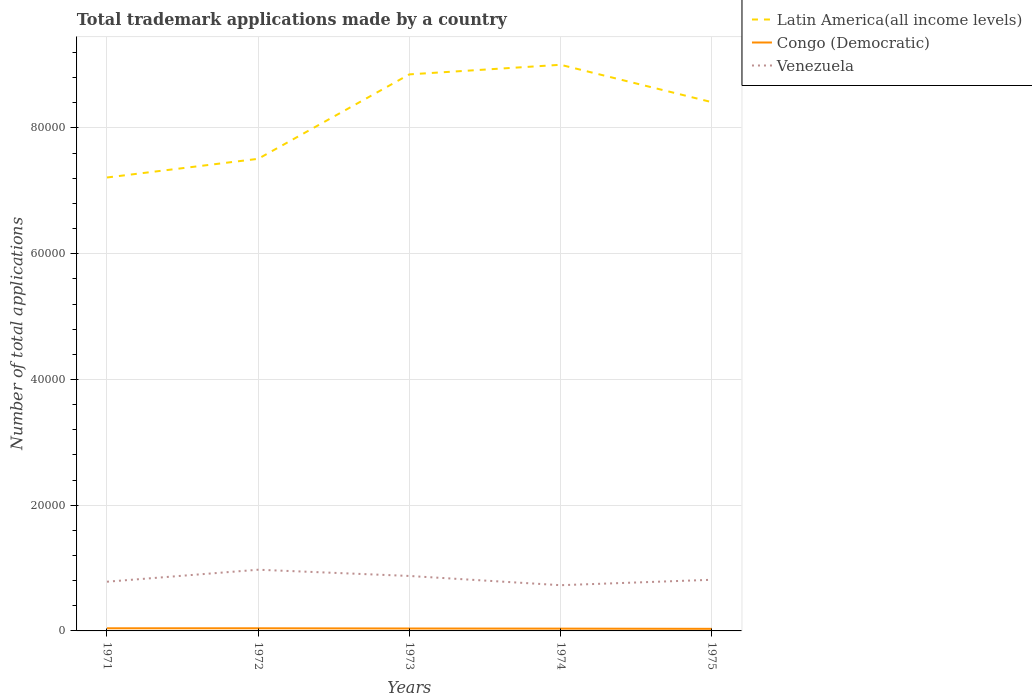Across all years, what is the maximum number of applications made by in Congo (Democratic)?
Keep it short and to the point. 334. In which year was the number of applications made by in Venezuela maximum?
Ensure brevity in your answer.  1974. What is the total number of applications made by in Congo (Democratic) in the graph?
Your answer should be very brief. 86. What is the difference between the highest and the lowest number of applications made by in Venezuela?
Ensure brevity in your answer.  2. Is the number of applications made by in Congo (Democratic) strictly greater than the number of applications made by in Latin America(all income levels) over the years?
Your response must be concise. Yes. Are the values on the major ticks of Y-axis written in scientific E-notation?
Make the answer very short. No. Does the graph contain any zero values?
Provide a short and direct response. No. Where does the legend appear in the graph?
Make the answer very short. Top right. How many legend labels are there?
Offer a very short reply. 3. What is the title of the graph?
Make the answer very short. Total trademark applications made by a country. What is the label or title of the Y-axis?
Provide a short and direct response. Number of total applications. What is the Number of total applications in Latin America(all income levels) in 1971?
Provide a succinct answer. 7.21e+04. What is the Number of total applications of Congo (Democratic) in 1971?
Provide a succinct answer. 421. What is the Number of total applications in Venezuela in 1971?
Offer a very short reply. 7827. What is the Number of total applications of Latin America(all income levels) in 1972?
Keep it short and to the point. 7.51e+04. What is the Number of total applications of Congo (Democratic) in 1972?
Keep it short and to the point. 420. What is the Number of total applications in Venezuela in 1972?
Your answer should be very brief. 9735. What is the Number of total applications in Latin America(all income levels) in 1973?
Offer a very short reply. 8.85e+04. What is the Number of total applications of Congo (Democratic) in 1973?
Offer a terse response. 384. What is the Number of total applications of Venezuela in 1973?
Your answer should be compact. 8742. What is the Number of total applications of Latin America(all income levels) in 1974?
Keep it short and to the point. 9.01e+04. What is the Number of total applications of Congo (Democratic) in 1974?
Give a very brief answer. 366. What is the Number of total applications of Venezuela in 1974?
Offer a very short reply. 7272. What is the Number of total applications of Latin America(all income levels) in 1975?
Provide a succinct answer. 8.41e+04. What is the Number of total applications in Congo (Democratic) in 1975?
Ensure brevity in your answer.  334. What is the Number of total applications in Venezuela in 1975?
Provide a short and direct response. 8135. Across all years, what is the maximum Number of total applications in Latin America(all income levels)?
Offer a very short reply. 9.01e+04. Across all years, what is the maximum Number of total applications of Congo (Democratic)?
Keep it short and to the point. 421. Across all years, what is the maximum Number of total applications of Venezuela?
Make the answer very short. 9735. Across all years, what is the minimum Number of total applications in Latin America(all income levels)?
Your answer should be very brief. 7.21e+04. Across all years, what is the minimum Number of total applications in Congo (Democratic)?
Offer a very short reply. 334. Across all years, what is the minimum Number of total applications in Venezuela?
Make the answer very short. 7272. What is the total Number of total applications in Latin America(all income levels) in the graph?
Your answer should be very brief. 4.10e+05. What is the total Number of total applications of Congo (Democratic) in the graph?
Offer a very short reply. 1925. What is the total Number of total applications of Venezuela in the graph?
Provide a succinct answer. 4.17e+04. What is the difference between the Number of total applications of Latin America(all income levels) in 1971 and that in 1972?
Give a very brief answer. -2970. What is the difference between the Number of total applications in Congo (Democratic) in 1971 and that in 1972?
Your answer should be very brief. 1. What is the difference between the Number of total applications in Venezuela in 1971 and that in 1972?
Your answer should be very brief. -1908. What is the difference between the Number of total applications in Latin America(all income levels) in 1971 and that in 1973?
Offer a very short reply. -1.64e+04. What is the difference between the Number of total applications of Congo (Democratic) in 1971 and that in 1973?
Offer a terse response. 37. What is the difference between the Number of total applications in Venezuela in 1971 and that in 1973?
Your answer should be compact. -915. What is the difference between the Number of total applications in Latin America(all income levels) in 1971 and that in 1974?
Make the answer very short. -1.79e+04. What is the difference between the Number of total applications of Venezuela in 1971 and that in 1974?
Offer a terse response. 555. What is the difference between the Number of total applications in Latin America(all income levels) in 1971 and that in 1975?
Your answer should be very brief. -1.20e+04. What is the difference between the Number of total applications in Venezuela in 1971 and that in 1975?
Give a very brief answer. -308. What is the difference between the Number of total applications of Latin America(all income levels) in 1972 and that in 1973?
Your answer should be compact. -1.34e+04. What is the difference between the Number of total applications in Congo (Democratic) in 1972 and that in 1973?
Your response must be concise. 36. What is the difference between the Number of total applications of Venezuela in 1972 and that in 1973?
Your answer should be very brief. 993. What is the difference between the Number of total applications of Latin America(all income levels) in 1972 and that in 1974?
Ensure brevity in your answer.  -1.50e+04. What is the difference between the Number of total applications of Venezuela in 1972 and that in 1974?
Your response must be concise. 2463. What is the difference between the Number of total applications of Latin America(all income levels) in 1972 and that in 1975?
Keep it short and to the point. -9015. What is the difference between the Number of total applications of Venezuela in 1972 and that in 1975?
Provide a succinct answer. 1600. What is the difference between the Number of total applications of Latin America(all income levels) in 1973 and that in 1974?
Provide a short and direct response. -1526. What is the difference between the Number of total applications in Congo (Democratic) in 1973 and that in 1974?
Offer a terse response. 18. What is the difference between the Number of total applications of Venezuela in 1973 and that in 1974?
Make the answer very short. 1470. What is the difference between the Number of total applications of Latin America(all income levels) in 1973 and that in 1975?
Provide a short and direct response. 4417. What is the difference between the Number of total applications in Venezuela in 1973 and that in 1975?
Make the answer very short. 607. What is the difference between the Number of total applications of Latin America(all income levels) in 1974 and that in 1975?
Give a very brief answer. 5943. What is the difference between the Number of total applications of Congo (Democratic) in 1974 and that in 1975?
Give a very brief answer. 32. What is the difference between the Number of total applications of Venezuela in 1974 and that in 1975?
Offer a terse response. -863. What is the difference between the Number of total applications of Latin America(all income levels) in 1971 and the Number of total applications of Congo (Democratic) in 1972?
Give a very brief answer. 7.17e+04. What is the difference between the Number of total applications in Latin America(all income levels) in 1971 and the Number of total applications in Venezuela in 1972?
Ensure brevity in your answer.  6.24e+04. What is the difference between the Number of total applications of Congo (Democratic) in 1971 and the Number of total applications of Venezuela in 1972?
Offer a very short reply. -9314. What is the difference between the Number of total applications in Latin America(all income levels) in 1971 and the Number of total applications in Congo (Democratic) in 1973?
Your answer should be compact. 7.17e+04. What is the difference between the Number of total applications in Latin America(all income levels) in 1971 and the Number of total applications in Venezuela in 1973?
Your answer should be compact. 6.34e+04. What is the difference between the Number of total applications of Congo (Democratic) in 1971 and the Number of total applications of Venezuela in 1973?
Keep it short and to the point. -8321. What is the difference between the Number of total applications of Latin America(all income levels) in 1971 and the Number of total applications of Congo (Democratic) in 1974?
Provide a succinct answer. 7.18e+04. What is the difference between the Number of total applications in Latin America(all income levels) in 1971 and the Number of total applications in Venezuela in 1974?
Your answer should be compact. 6.49e+04. What is the difference between the Number of total applications in Congo (Democratic) in 1971 and the Number of total applications in Venezuela in 1974?
Keep it short and to the point. -6851. What is the difference between the Number of total applications of Latin America(all income levels) in 1971 and the Number of total applications of Congo (Democratic) in 1975?
Keep it short and to the point. 7.18e+04. What is the difference between the Number of total applications of Latin America(all income levels) in 1971 and the Number of total applications of Venezuela in 1975?
Provide a succinct answer. 6.40e+04. What is the difference between the Number of total applications of Congo (Democratic) in 1971 and the Number of total applications of Venezuela in 1975?
Your answer should be compact. -7714. What is the difference between the Number of total applications of Latin America(all income levels) in 1972 and the Number of total applications of Congo (Democratic) in 1973?
Keep it short and to the point. 7.47e+04. What is the difference between the Number of total applications of Latin America(all income levels) in 1972 and the Number of total applications of Venezuela in 1973?
Your answer should be compact. 6.64e+04. What is the difference between the Number of total applications in Congo (Democratic) in 1972 and the Number of total applications in Venezuela in 1973?
Your response must be concise. -8322. What is the difference between the Number of total applications in Latin America(all income levels) in 1972 and the Number of total applications in Congo (Democratic) in 1974?
Give a very brief answer. 7.47e+04. What is the difference between the Number of total applications in Latin America(all income levels) in 1972 and the Number of total applications in Venezuela in 1974?
Give a very brief answer. 6.78e+04. What is the difference between the Number of total applications in Congo (Democratic) in 1972 and the Number of total applications in Venezuela in 1974?
Offer a terse response. -6852. What is the difference between the Number of total applications in Latin America(all income levels) in 1972 and the Number of total applications in Congo (Democratic) in 1975?
Provide a short and direct response. 7.48e+04. What is the difference between the Number of total applications in Latin America(all income levels) in 1972 and the Number of total applications in Venezuela in 1975?
Provide a short and direct response. 6.70e+04. What is the difference between the Number of total applications of Congo (Democratic) in 1972 and the Number of total applications of Venezuela in 1975?
Your answer should be compact. -7715. What is the difference between the Number of total applications in Latin America(all income levels) in 1973 and the Number of total applications in Congo (Democratic) in 1974?
Your answer should be compact. 8.82e+04. What is the difference between the Number of total applications in Latin America(all income levels) in 1973 and the Number of total applications in Venezuela in 1974?
Offer a very short reply. 8.13e+04. What is the difference between the Number of total applications of Congo (Democratic) in 1973 and the Number of total applications of Venezuela in 1974?
Your response must be concise. -6888. What is the difference between the Number of total applications in Latin America(all income levels) in 1973 and the Number of total applications in Congo (Democratic) in 1975?
Offer a very short reply. 8.82e+04. What is the difference between the Number of total applications in Latin America(all income levels) in 1973 and the Number of total applications in Venezuela in 1975?
Your answer should be very brief. 8.04e+04. What is the difference between the Number of total applications in Congo (Democratic) in 1973 and the Number of total applications in Venezuela in 1975?
Make the answer very short. -7751. What is the difference between the Number of total applications of Latin America(all income levels) in 1974 and the Number of total applications of Congo (Democratic) in 1975?
Keep it short and to the point. 8.97e+04. What is the difference between the Number of total applications in Latin America(all income levels) in 1974 and the Number of total applications in Venezuela in 1975?
Ensure brevity in your answer.  8.19e+04. What is the difference between the Number of total applications in Congo (Democratic) in 1974 and the Number of total applications in Venezuela in 1975?
Your response must be concise. -7769. What is the average Number of total applications of Latin America(all income levels) per year?
Provide a short and direct response. 8.20e+04. What is the average Number of total applications of Congo (Democratic) per year?
Your answer should be very brief. 385. What is the average Number of total applications of Venezuela per year?
Offer a terse response. 8342.2. In the year 1971, what is the difference between the Number of total applications of Latin America(all income levels) and Number of total applications of Congo (Democratic)?
Give a very brief answer. 7.17e+04. In the year 1971, what is the difference between the Number of total applications in Latin America(all income levels) and Number of total applications in Venezuela?
Offer a terse response. 6.43e+04. In the year 1971, what is the difference between the Number of total applications of Congo (Democratic) and Number of total applications of Venezuela?
Make the answer very short. -7406. In the year 1972, what is the difference between the Number of total applications in Latin America(all income levels) and Number of total applications in Congo (Democratic)?
Your answer should be compact. 7.47e+04. In the year 1972, what is the difference between the Number of total applications of Latin America(all income levels) and Number of total applications of Venezuela?
Provide a succinct answer. 6.54e+04. In the year 1972, what is the difference between the Number of total applications of Congo (Democratic) and Number of total applications of Venezuela?
Give a very brief answer. -9315. In the year 1973, what is the difference between the Number of total applications in Latin America(all income levels) and Number of total applications in Congo (Democratic)?
Give a very brief answer. 8.81e+04. In the year 1973, what is the difference between the Number of total applications in Latin America(all income levels) and Number of total applications in Venezuela?
Your answer should be very brief. 7.98e+04. In the year 1973, what is the difference between the Number of total applications in Congo (Democratic) and Number of total applications in Venezuela?
Your response must be concise. -8358. In the year 1974, what is the difference between the Number of total applications of Latin America(all income levels) and Number of total applications of Congo (Democratic)?
Provide a succinct answer. 8.97e+04. In the year 1974, what is the difference between the Number of total applications of Latin America(all income levels) and Number of total applications of Venezuela?
Provide a succinct answer. 8.28e+04. In the year 1974, what is the difference between the Number of total applications in Congo (Democratic) and Number of total applications in Venezuela?
Your answer should be compact. -6906. In the year 1975, what is the difference between the Number of total applications of Latin America(all income levels) and Number of total applications of Congo (Democratic)?
Keep it short and to the point. 8.38e+04. In the year 1975, what is the difference between the Number of total applications in Latin America(all income levels) and Number of total applications in Venezuela?
Make the answer very short. 7.60e+04. In the year 1975, what is the difference between the Number of total applications of Congo (Democratic) and Number of total applications of Venezuela?
Make the answer very short. -7801. What is the ratio of the Number of total applications of Latin America(all income levels) in 1971 to that in 1972?
Your response must be concise. 0.96. What is the ratio of the Number of total applications of Congo (Democratic) in 1971 to that in 1972?
Provide a short and direct response. 1. What is the ratio of the Number of total applications in Venezuela in 1971 to that in 1972?
Provide a succinct answer. 0.8. What is the ratio of the Number of total applications in Latin America(all income levels) in 1971 to that in 1973?
Provide a succinct answer. 0.81. What is the ratio of the Number of total applications of Congo (Democratic) in 1971 to that in 1973?
Your response must be concise. 1.1. What is the ratio of the Number of total applications of Venezuela in 1971 to that in 1973?
Your answer should be very brief. 0.9. What is the ratio of the Number of total applications in Latin America(all income levels) in 1971 to that in 1974?
Your answer should be very brief. 0.8. What is the ratio of the Number of total applications of Congo (Democratic) in 1971 to that in 1974?
Provide a succinct answer. 1.15. What is the ratio of the Number of total applications of Venezuela in 1971 to that in 1974?
Offer a very short reply. 1.08. What is the ratio of the Number of total applications of Latin America(all income levels) in 1971 to that in 1975?
Your answer should be compact. 0.86. What is the ratio of the Number of total applications in Congo (Democratic) in 1971 to that in 1975?
Offer a terse response. 1.26. What is the ratio of the Number of total applications of Venezuela in 1971 to that in 1975?
Offer a very short reply. 0.96. What is the ratio of the Number of total applications of Latin America(all income levels) in 1972 to that in 1973?
Offer a terse response. 0.85. What is the ratio of the Number of total applications of Congo (Democratic) in 1972 to that in 1973?
Your answer should be compact. 1.09. What is the ratio of the Number of total applications of Venezuela in 1972 to that in 1973?
Provide a succinct answer. 1.11. What is the ratio of the Number of total applications of Latin America(all income levels) in 1972 to that in 1974?
Your answer should be compact. 0.83. What is the ratio of the Number of total applications of Congo (Democratic) in 1972 to that in 1974?
Offer a very short reply. 1.15. What is the ratio of the Number of total applications in Venezuela in 1972 to that in 1974?
Make the answer very short. 1.34. What is the ratio of the Number of total applications of Latin America(all income levels) in 1972 to that in 1975?
Your response must be concise. 0.89. What is the ratio of the Number of total applications in Congo (Democratic) in 1972 to that in 1975?
Provide a short and direct response. 1.26. What is the ratio of the Number of total applications in Venezuela in 1972 to that in 1975?
Ensure brevity in your answer.  1.2. What is the ratio of the Number of total applications of Latin America(all income levels) in 1973 to that in 1974?
Offer a terse response. 0.98. What is the ratio of the Number of total applications in Congo (Democratic) in 1973 to that in 1974?
Make the answer very short. 1.05. What is the ratio of the Number of total applications in Venezuela in 1973 to that in 1974?
Give a very brief answer. 1.2. What is the ratio of the Number of total applications of Latin America(all income levels) in 1973 to that in 1975?
Offer a terse response. 1.05. What is the ratio of the Number of total applications of Congo (Democratic) in 1973 to that in 1975?
Keep it short and to the point. 1.15. What is the ratio of the Number of total applications of Venezuela in 1973 to that in 1975?
Provide a succinct answer. 1.07. What is the ratio of the Number of total applications of Latin America(all income levels) in 1974 to that in 1975?
Provide a succinct answer. 1.07. What is the ratio of the Number of total applications of Congo (Democratic) in 1974 to that in 1975?
Keep it short and to the point. 1.1. What is the ratio of the Number of total applications of Venezuela in 1974 to that in 1975?
Provide a short and direct response. 0.89. What is the difference between the highest and the second highest Number of total applications of Latin America(all income levels)?
Your answer should be very brief. 1526. What is the difference between the highest and the second highest Number of total applications in Congo (Democratic)?
Provide a succinct answer. 1. What is the difference between the highest and the second highest Number of total applications of Venezuela?
Offer a terse response. 993. What is the difference between the highest and the lowest Number of total applications in Latin America(all income levels)?
Your answer should be compact. 1.79e+04. What is the difference between the highest and the lowest Number of total applications in Congo (Democratic)?
Provide a succinct answer. 87. What is the difference between the highest and the lowest Number of total applications of Venezuela?
Ensure brevity in your answer.  2463. 